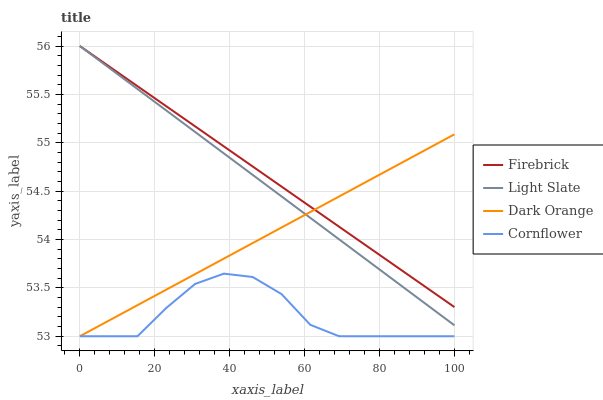Does Cornflower have the minimum area under the curve?
Answer yes or no. Yes. Does Firebrick have the maximum area under the curve?
Answer yes or no. Yes. Does Dark Orange have the minimum area under the curve?
Answer yes or no. No. Does Dark Orange have the maximum area under the curve?
Answer yes or no. No. Is Light Slate the smoothest?
Answer yes or no. Yes. Is Cornflower the roughest?
Answer yes or no. Yes. Is Dark Orange the smoothest?
Answer yes or no. No. Is Dark Orange the roughest?
Answer yes or no. No. Does Dark Orange have the lowest value?
Answer yes or no. Yes. Does Firebrick have the lowest value?
Answer yes or no. No. Does Firebrick have the highest value?
Answer yes or no. Yes. Does Dark Orange have the highest value?
Answer yes or no. No. Is Cornflower less than Light Slate?
Answer yes or no. Yes. Is Firebrick greater than Cornflower?
Answer yes or no. Yes. Does Light Slate intersect Dark Orange?
Answer yes or no. Yes. Is Light Slate less than Dark Orange?
Answer yes or no. No. Is Light Slate greater than Dark Orange?
Answer yes or no. No. Does Cornflower intersect Light Slate?
Answer yes or no. No. 